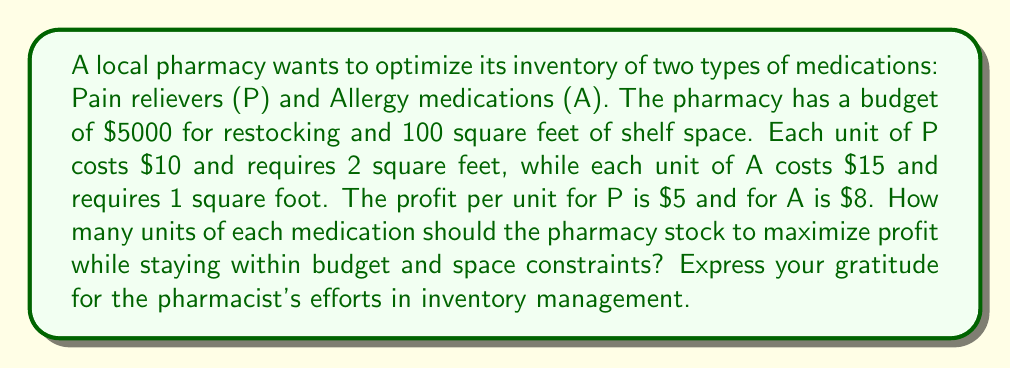Can you answer this question? Let's approach this problem using linear programming:

1. Define variables:
   $x$ = number of units of Pain relievers (P)
   $y$ = number of units of Allergy medications (A)

2. Objective function (maximize profit):
   $\text{Maximize } Z = 5x + 8y$

3. Constraints:
   Budget constraint: $10x + 15y \leq 5000$
   Space constraint: $2x + y \leq 100$
   Non-negativity: $x \geq 0, y \geq 0$

4. Solve using the graphical method:

   a) Plot the constraints:
      Budget: $y = -\frac{2}{3}x + \frac{1000}{3}$
      Space: $y = -2x + 100$

   b) Find the vertices of the feasible region:
      (0, 0), (0, 100), (50, 0), and the intersection point

   c) Intersection point:
      $-\frac{2}{3}x + \frac{1000}{3} = -2x + 100$
      $\frac{4}{3}x = \frac{200}{3}$
      $x = 50$
      $y = -2(50) + 100 = 0$

   d) Evaluate the objective function at each vertex:
      (0, 0): $Z = 0$
      (0, 100): $Z = 800$
      (50, 0): $Z = 250$
      (50, 0): $Z = 250$

5. The maximum profit occurs at (0, 100), which means stocking 0 units of P and 100 units of A.
Answer: The pharmacy should stock 0 units of Pain relievers (P) and 100 units of Allergy medications (A) to maximize profit. This will result in a profit of $800. 